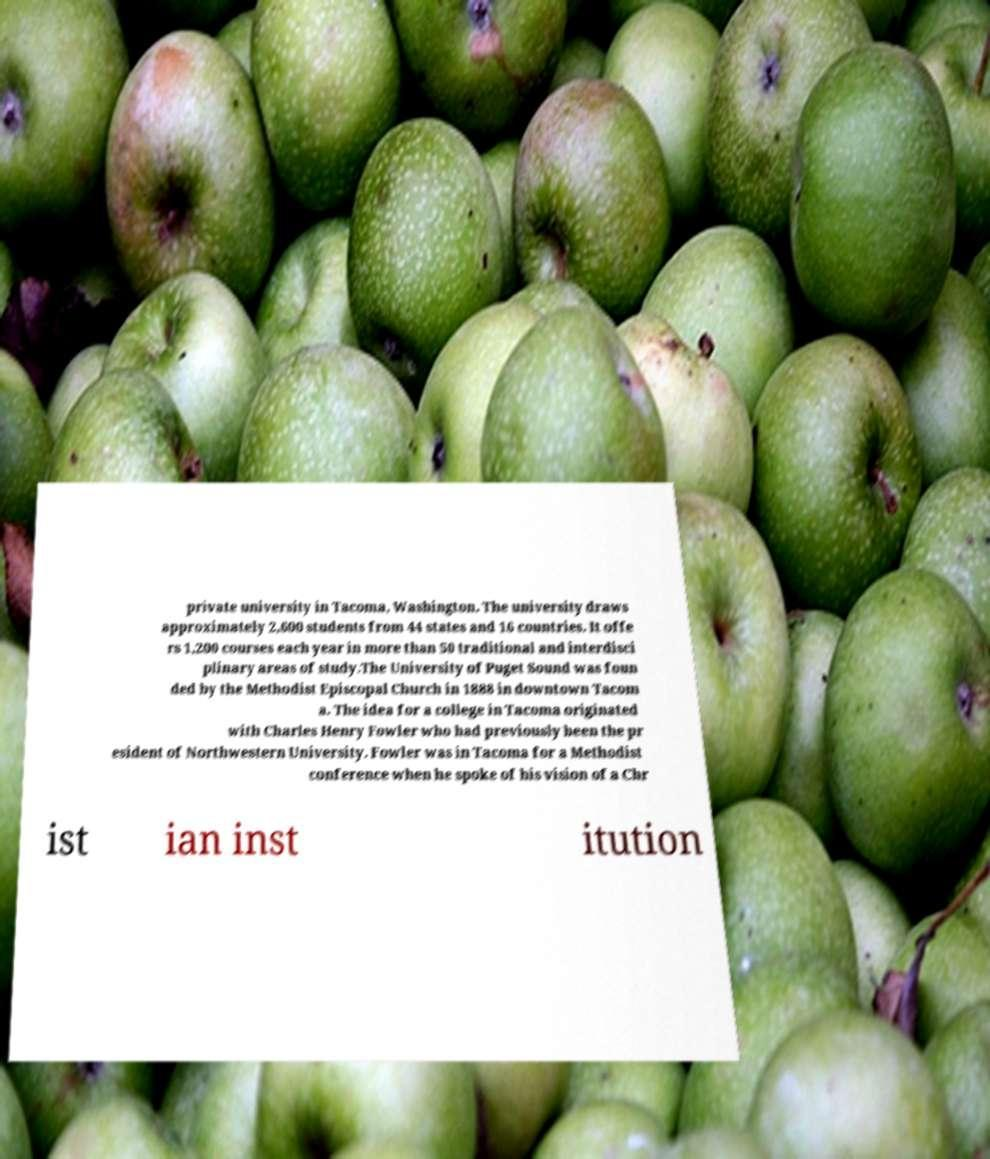For documentation purposes, I need the text within this image transcribed. Could you provide that? private university in Tacoma, Washington. The university draws approximately 2,600 students from 44 states and 16 countries. It offe rs 1,200 courses each year in more than 50 traditional and interdisci plinary areas of study.The University of Puget Sound was foun ded by the Methodist Episcopal Church in 1888 in downtown Tacom a. The idea for a college in Tacoma originated with Charles Henry Fowler who had previously been the pr esident of Northwestern University. Fowler was in Tacoma for a Methodist conference when he spoke of his vision of a Chr ist ian inst itution 